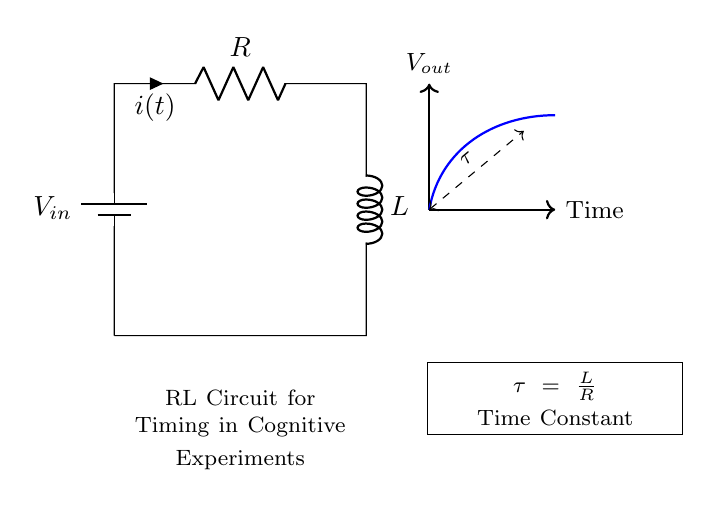What is the input voltage of the circuit? The input voltage is labeled as V-in in the circuit diagram. It represents the voltage supplied to the circuit.
Answer: V-in What type of circuit is shown in the diagram? The diagram shows an RL circuit, which consists of a resistor and an inductor connected in series. This is identified by the presence of both R and L components.
Answer: RL circuit What is the value of the time constant in the circuit? The time constant, tau, is given by the formula tau equals L divided by R in the diagram, indicating how quickly the circuit responds to changes.
Answer: tau = L/R What does the direction of the current indicate? The current, indicated by the arrow labeled i(t), flows from the positive terminal of the battery through the resistor and then into the inductor, which shows the direction of flow in the circuit.
Answer: From battery to inductor How does the resistance affect the time constant? The time constant tau is inversely related to resistance R; as R increases, tau decreases, meaning the circuit takes longer to respond to voltage changes. This involves understanding the relationship given in the formula tau equals L divided by R.
Answer: Inversely related What does the dashed line represent? The dashed line labeled tau represents the duration of the time constant in the circuit, indicating the time it takes for the current or voltage to reach approximately 63.2 percent of its final value after a step change.
Answer: Time constant duration 